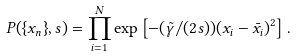Convert formula to latex. <formula><loc_0><loc_0><loc_500><loc_500>P ( \{ x _ { n } \} , s ) = \prod _ { i = 1 } ^ { N } \exp \left [ - ( \tilde { \gamma } / ( 2 s ) ) ( x _ { i } - \bar { x } _ { i } ) ^ { 2 } \right ] .</formula> 